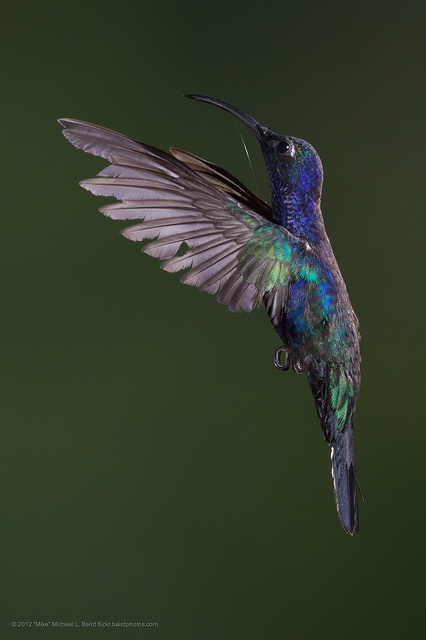Describe the objects in this image and their specific colors. I can see a bird in black, gray, darkgray, and navy tones in this image. 